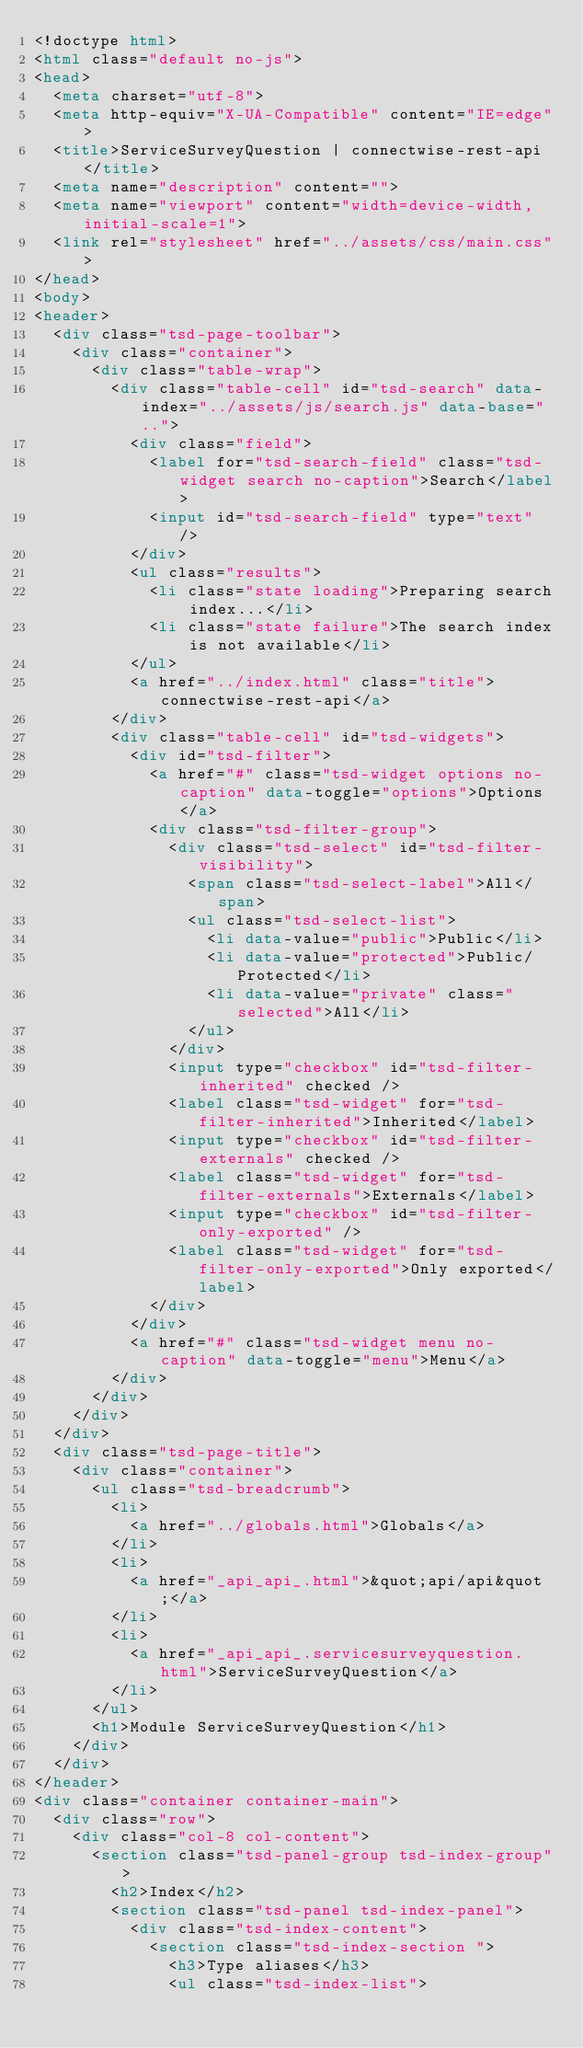Convert code to text. <code><loc_0><loc_0><loc_500><loc_500><_HTML_><!doctype html>
<html class="default no-js">
<head>
	<meta charset="utf-8">
	<meta http-equiv="X-UA-Compatible" content="IE=edge">
	<title>ServiceSurveyQuestion | connectwise-rest-api</title>
	<meta name="description" content="">
	<meta name="viewport" content="width=device-width, initial-scale=1">
	<link rel="stylesheet" href="../assets/css/main.css">
</head>
<body>
<header>
	<div class="tsd-page-toolbar">
		<div class="container">
			<div class="table-wrap">
				<div class="table-cell" id="tsd-search" data-index="../assets/js/search.js" data-base="..">
					<div class="field">
						<label for="tsd-search-field" class="tsd-widget search no-caption">Search</label>
						<input id="tsd-search-field" type="text" />
					</div>
					<ul class="results">
						<li class="state loading">Preparing search index...</li>
						<li class="state failure">The search index is not available</li>
					</ul>
					<a href="../index.html" class="title">connectwise-rest-api</a>
				</div>
				<div class="table-cell" id="tsd-widgets">
					<div id="tsd-filter">
						<a href="#" class="tsd-widget options no-caption" data-toggle="options">Options</a>
						<div class="tsd-filter-group">
							<div class="tsd-select" id="tsd-filter-visibility">
								<span class="tsd-select-label">All</span>
								<ul class="tsd-select-list">
									<li data-value="public">Public</li>
									<li data-value="protected">Public/Protected</li>
									<li data-value="private" class="selected">All</li>
								</ul>
							</div>
							<input type="checkbox" id="tsd-filter-inherited" checked />
							<label class="tsd-widget" for="tsd-filter-inherited">Inherited</label>
							<input type="checkbox" id="tsd-filter-externals" checked />
							<label class="tsd-widget" for="tsd-filter-externals">Externals</label>
							<input type="checkbox" id="tsd-filter-only-exported" />
							<label class="tsd-widget" for="tsd-filter-only-exported">Only exported</label>
						</div>
					</div>
					<a href="#" class="tsd-widget menu no-caption" data-toggle="menu">Menu</a>
				</div>
			</div>
		</div>
	</div>
	<div class="tsd-page-title">
		<div class="container">
			<ul class="tsd-breadcrumb">
				<li>
					<a href="../globals.html">Globals</a>
				</li>
				<li>
					<a href="_api_api_.html">&quot;api/api&quot;</a>
				</li>
				<li>
					<a href="_api_api_.servicesurveyquestion.html">ServiceSurveyQuestion</a>
				</li>
			</ul>
			<h1>Module ServiceSurveyQuestion</h1>
		</div>
	</div>
</header>
<div class="container container-main">
	<div class="row">
		<div class="col-8 col-content">
			<section class="tsd-panel-group tsd-index-group">
				<h2>Index</h2>
				<section class="tsd-panel tsd-index-panel">
					<div class="tsd-index-content">
						<section class="tsd-index-section ">
							<h3>Type aliases</h3>
							<ul class="tsd-index-list"></code> 